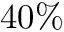<formula> <loc_0><loc_0><loc_500><loc_500>4 0 \%</formula> 